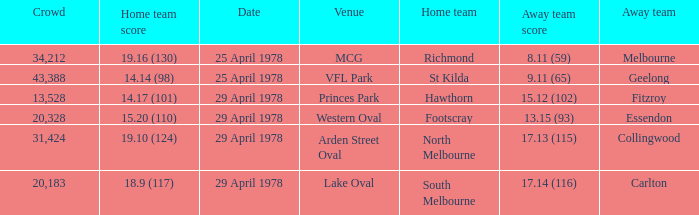Who was the home team at MCG? Richmond. 